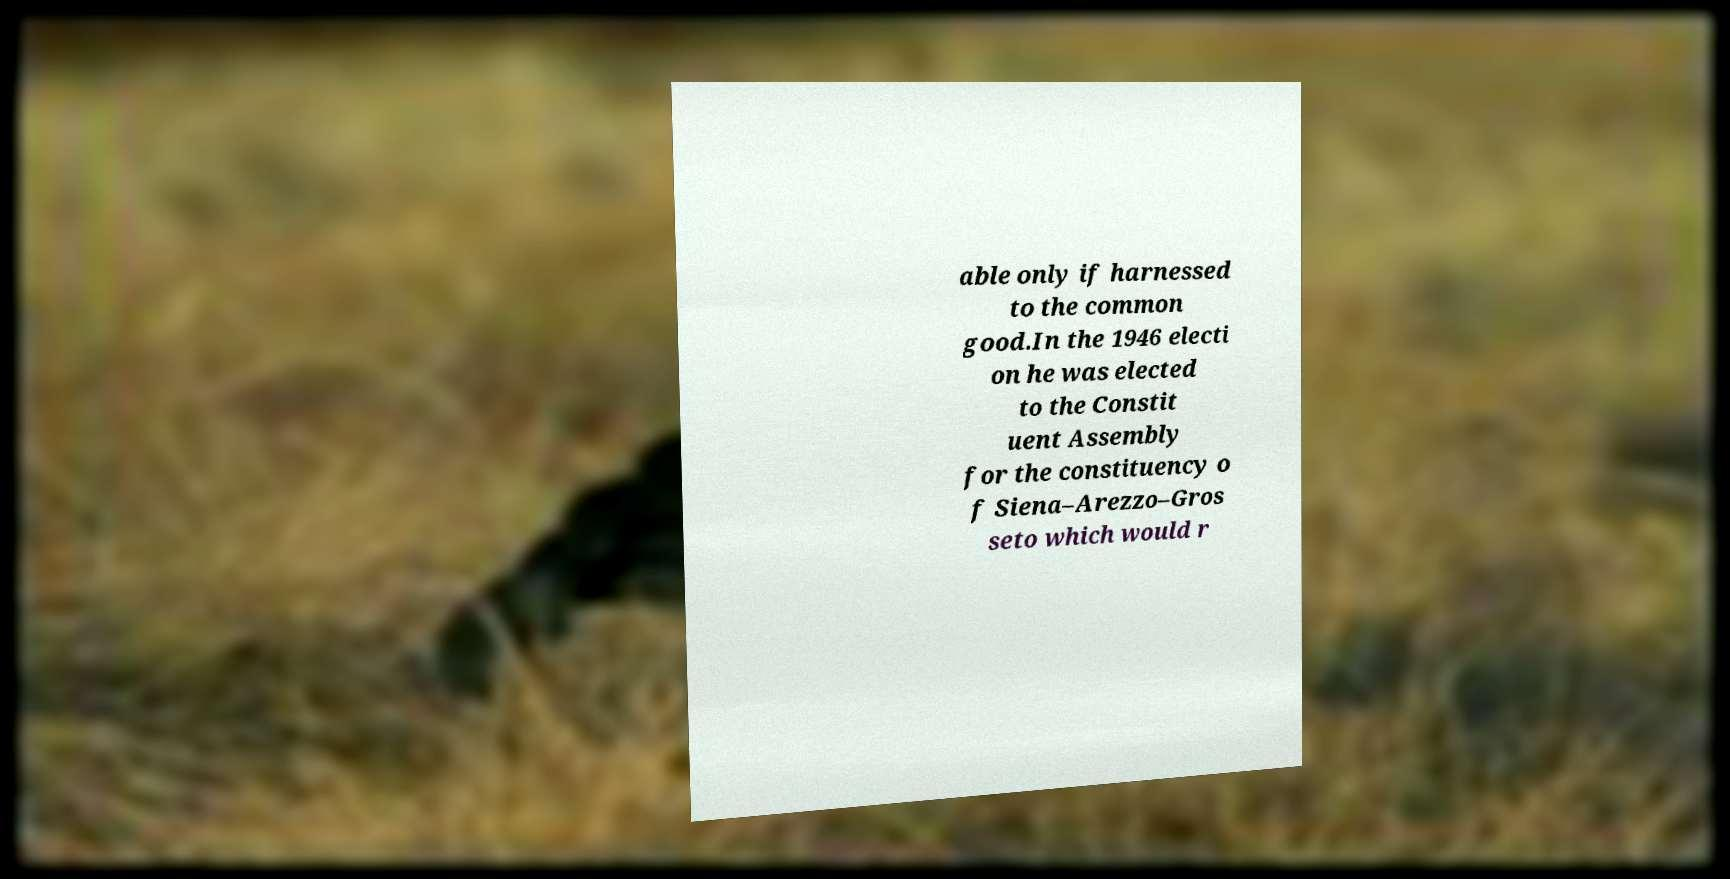There's text embedded in this image that I need extracted. Can you transcribe it verbatim? able only if harnessed to the common good.In the 1946 electi on he was elected to the Constit uent Assembly for the constituency o f Siena–Arezzo–Gros seto which would r 